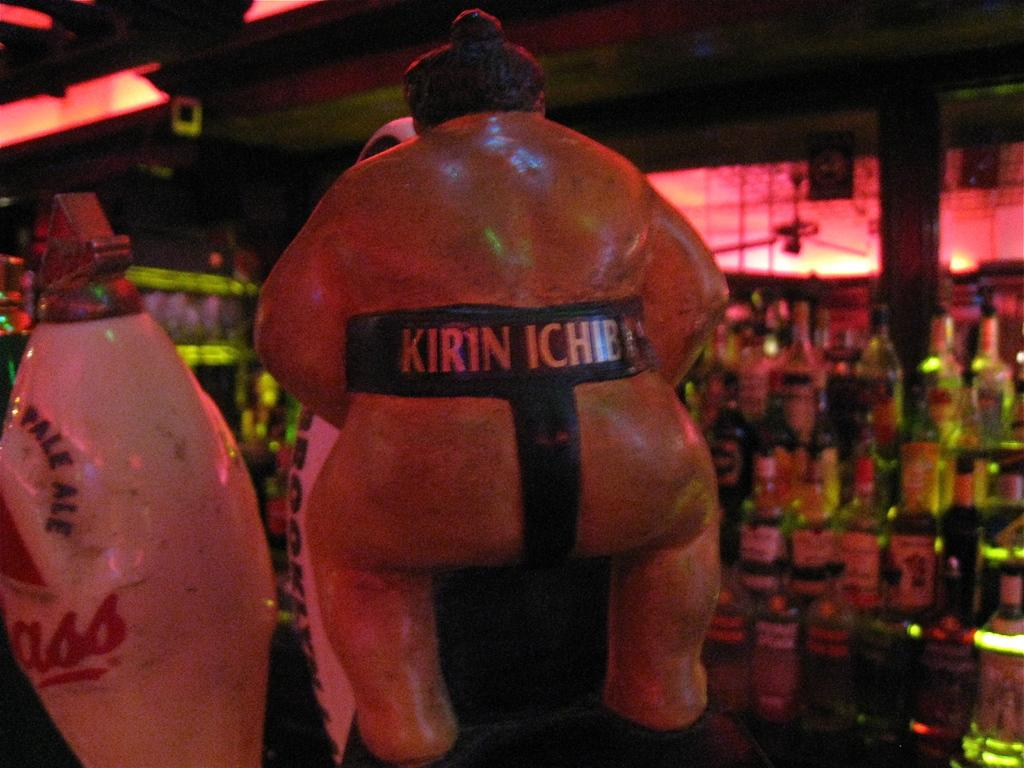What is the main object in the center of the image? There is a toy in the center of the image. What can be seen in the background of the image? There are beverage bottles arranged in shelves and a pillar visible in the background. What type of structure is present in the background? There is a wall in the background. What channel is the toy tuned to in the image? The toy does not have a channel, as it is not an electronic device. 